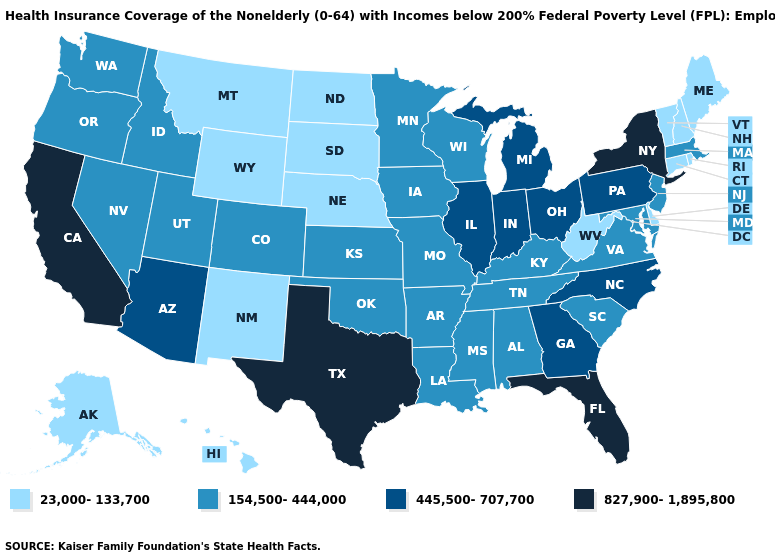What is the value of Washington?
Answer briefly. 154,500-444,000. Does North Carolina have a lower value than North Dakota?
Keep it brief. No. Does the first symbol in the legend represent the smallest category?
Write a very short answer. Yes. Name the states that have a value in the range 23,000-133,700?
Be succinct. Alaska, Connecticut, Delaware, Hawaii, Maine, Montana, Nebraska, New Hampshire, New Mexico, North Dakota, Rhode Island, South Dakota, Vermont, West Virginia, Wyoming. Does South Dakota have the same value as Connecticut?
Quick response, please. Yes. Name the states that have a value in the range 23,000-133,700?
Write a very short answer. Alaska, Connecticut, Delaware, Hawaii, Maine, Montana, Nebraska, New Hampshire, New Mexico, North Dakota, Rhode Island, South Dakota, Vermont, West Virginia, Wyoming. What is the value of Florida?
Quick response, please. 827,900-1,895,800. What is the value of California?
Short answer required. 827,900-1,895,800. Name the states that have a value in the range 23,000-133,700?
Keep it brief. Alaska, Connecticut, Delaware, Hawaii, Maine, Montana, Nebraska, New Hampshire, New Mexico, North Dakota, Rhode Island, South Dakota, Vermont, West Virginia, Wyoming. Does Georgia have a lower value than Hawaii?
Answer briefly. No. What is the highest value in the West ?
Be succinct. 827,900-1,895,800. Name the states that have a value in the range 154,500-444,000?
Keep it brief. Alabama, Arkansas, Colorado, Idaho, Iowa, Kansas, Kentucky, Louisiana, Maryland, Massachusetts, Minnesota, Mississippi, Missouri, Nevada, New Jersey, Oklahoma, Oregon, South Carolina, Tennessee, Utah, Virginia, Washington, Wisconsin. What is the highest value in the South ?
Concise answer only. 827,900-1,895,800. What is the value of Maryland?
Answer briefly. 154,500-444,000. How many symbols are there in the legend?
Keep it brief. 4. 